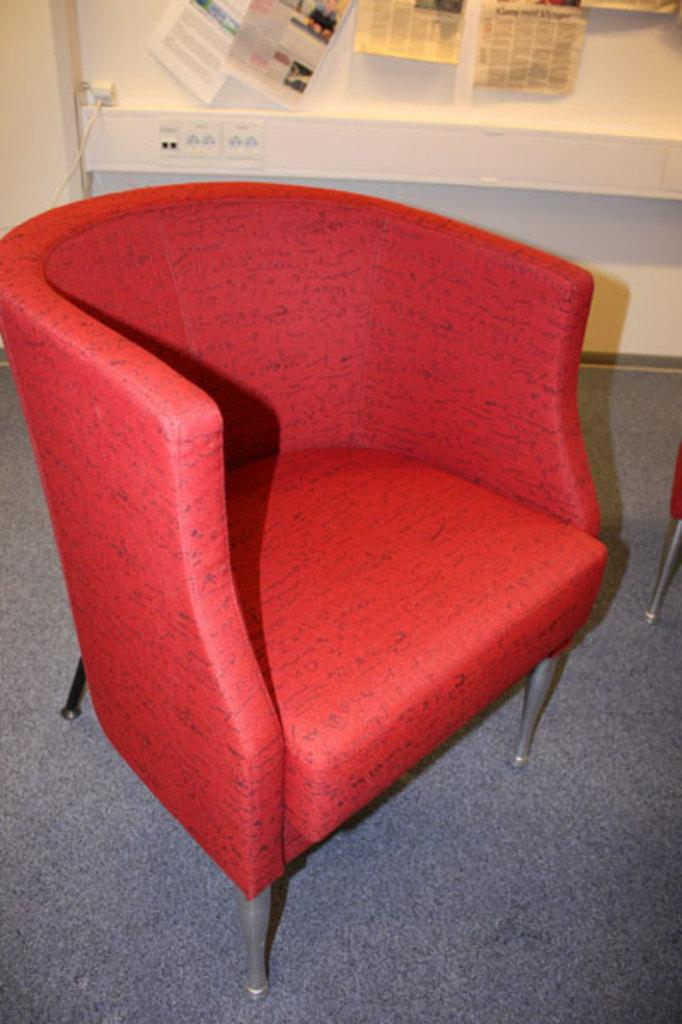What type of furniture can be seen in the image? There are chairs in the image. What type of floor covering is present in the image? There is a carpet in the image. What type of object is present that is typically used for transmitting signals or power? There is a cable wire in the image. What type of structure is present in the image that separates spaces? There is a wall in the image. What type of items are attached to the wall in the image? Papers are stuck to the wall in the image. How many chess pieces can be seen on the carpet in the image? There are no chess pieces present in the image. What type of ticket is visible on the wall in the image? There are no tickets visible on the wall in the image. 